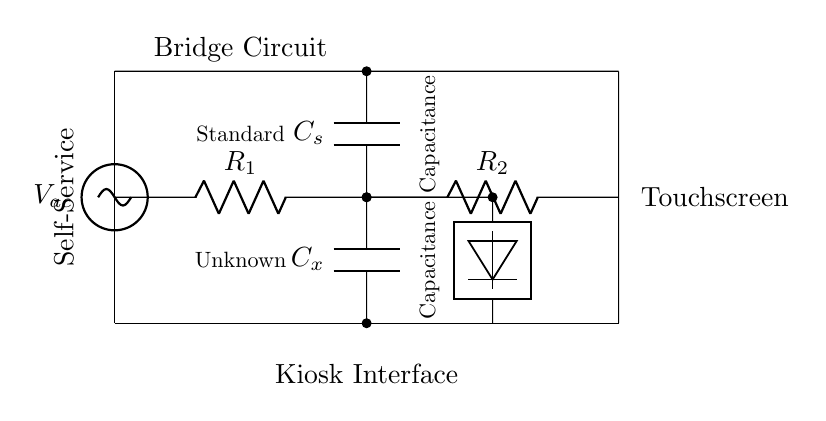What are the components in this circuit? The circuit contains two resistors, a capacitor labeled Cx, a standard capacitor labeled Cs, and a voltage source. These components can be identified by their respective symbols in the diagram.
Answer: resistors, capacitors, voltage source What is the value of the unknown capacitance? The unknown capacitance, Cx, is measured in the circuit and is determined by balancing the bridge. Since the diagram does not provide specific values, we cannot assign a numeric value.
Answer: unknown What type of circuit is represented? This is a capacitance bridge circuit, specifically designed to measure unknown capacitance by comparing it with a known capacitor in a balanced condition.
Answer: capacitance bridge What is the purpose of the sinusoidal voltage source in this circuit? The sinusoidal voltage source provides an alternating current signal that enables the circuit to operate in a way that allows the detection of changes in capacitance due to touch on the touchscreen interface.
Answer: alternating current signal How does the detection mechanism work in this bridge circuit? The detection mechanism likely functions by measuring the imbalance between the resistors and capacitors. As the capacitance changes due to a finger touch, the impedance of the circuit changes, which can be detected as a voltage difference or current change at the detector.
Answer: measures impedance changes What is the significance of the standard capacitor in this circuit? The standard capacitor serves as a reference value for comparison when measuring the unknown capacitance. It is essential for achieving balance in the bridge, thus enabling accurate measurements of Cx.
Answer: reference value 